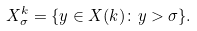<formula> <loc_0><loc_0><loc_500><loc_500>X ^ { k } _ { \sigma } = \{ y \in X ( k ) \colon y > \sigma \} .</formula> 